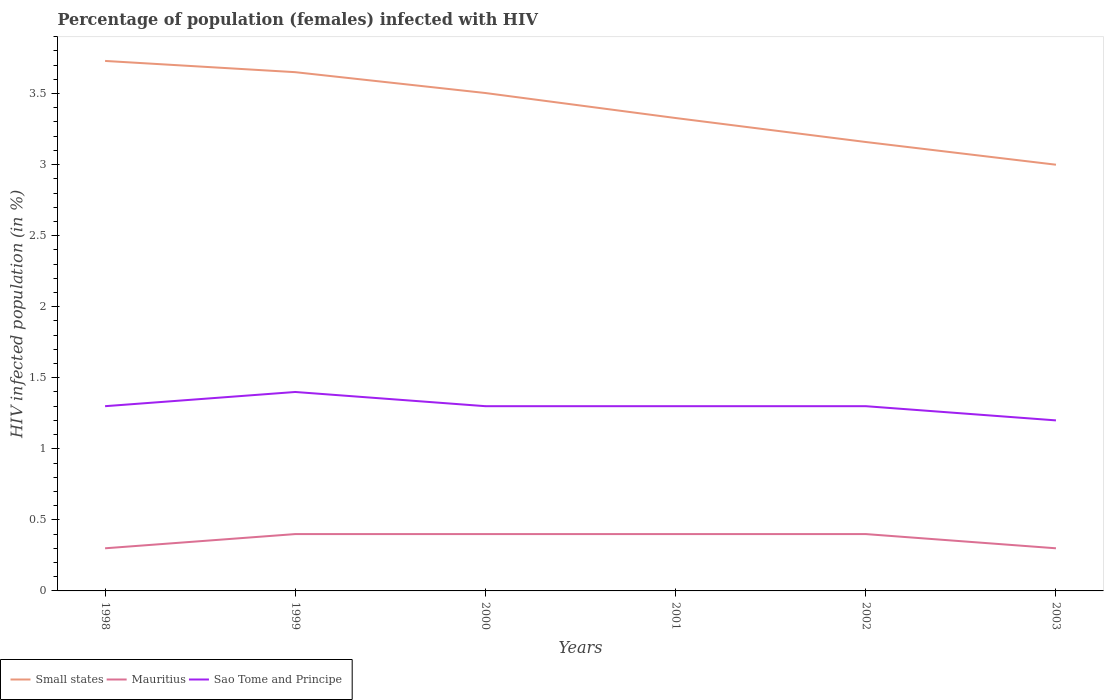How many different coloured lines are there?
Offer a terse response. 3. Does the line corresponding to Mauritius intersect with the line corresponding to Sao Tome and Principe?
Make the answer very short. No. Is the number of lines equal to the number of legend labels?
Give a very brief answer. Yes. Across all years, what is the maximum percentage of HIV infected female population in Small states?
Offer a terse response. 3. In which year was the percentage of HIV infected female population in Small states maximum?
Give a very brief answer. 2003. What is the total percentage of HIV infected female population in Mauritius in the graph?
Offer a very short reply. -0.1. What is the difference between the highest and the second highest percentage of HIV infected female population in Small states?
Provide a short and direct response. 0.73. What is the difference between the highest and the lowest percentage of HIV infected female population in Sao Tome and Principe?
Make the answer very short. 1. Is the percentage of HIV infected female population in Sao Tome and Principe strictly greater than the percentage of HIV infected female population in Mauritius over the years?
Your answer should be compact. No. How many lines are there?
Give a very brief answer. 3. How many years are there in the graph?
Ensure brevity in your answer.  6. Are the values on the major ticks of Y-axis written in scientific E-notation?
Ensure brevity in your answer.  No. Where does the legend appear in the graph?
Give a very brief answer. Bottom left. How many legend labels are there?
Ensure brevity in your answer.  3. What is the title of the graph?
Provide a succinct answer. Percentage of population (females) infected with HIV. What is the label or title of the X-axis?
Your response must be concise. Years. What is the label or title of the Y-axis?
Provide a succinct answer. HIV infected population (in %). What is the HIV infected population (in %) in Small states in 1998?
Offer a terse response. 3.73. What is the HIV infected population (in %) in Small states in 1999?
Provide a succinct answer. 3.65. What is the HIV infected population (in %) of Sao Tome and Principe in 1999?
Keep it short and to the point. 1.4. What is the HIV infected population (in %) in Small states in 2000?
Make the answer very short. 3.5. What is the HIV infected population (in %) in Mauritius in 2000?
Give a very brief answer. 0.4. What is the HIV infected population (in %) of Sao Tome and Principe in 2000?
Offer a terse response. 1.3. What is the HIV infected population (in %) of Small states in 2001?
Give a very brief answer. 3.33. What is the HIV infected population (in %) in Mauritius in 2001?
Provide a succinct answer. 0.4. What is the HIV infected population (in %) in Small states in 2002?
Your answer should be compact. 3.16. What is the HIV infected population (in %) of Mauritius in 2002?
Your answer should be very brief. 0.4. What is the HIV infected population (in %) of Small states in 2003?
Your answer should be compact. 3. Across all years, what is the maximum HIV infected population (in %) of Small states?
Give a very brief answer. 3.73. Across all years, what is the maximum HIV infected population (in %) of Mauritius?
Provide a short and direct response. 0.4. Across all years, what is the maximum HIV infected population (in %) of Sao Tome and Principe?
Your response must be concise. 1.4. Across all years, what is the minimum HIV infected population (in %) in Small states?
Your answer should be very brief. 3. Across all years, what is the minimum HIV infected population (in %) of Mauritius?
Make the answer very short. 0.3. What is the total HIV infected population (in %) of Small states in the graph?
Make the answer very short. 20.37. What is the total HIV infected population (in %) of Mauritius in the graph?
Give a very brief answer. 2.2. What is the difference between the HIV infected population (in %) of Small states in 1998 and that in 1999?
Ensure brevity in your answer.  0.08. What is the difference between the HIV infected population (in %) in Mauritius in 1998 and that in 1999?
Your response must be concise. -0.1. What is the difference between the HIV infected population (in %) of Sao Tome and Principe in 1998 and that in 1999?
Your answer should be very brief. -0.1. What is the difference between the HIV infected population (in %) in Small states in 1998 and that in 2000?
Keep it short and to the point. 0.23. What is the difference between the HIV infected population (in %) of Mauritius in 1998 and that in 2000?
Make the answer very short. -0.1. What is the difference between the HIV infected population (in %) in Sao Tome and Principe in 1998 and that in 2000?
Provide a succinct answer. 0. What is the difference between the HIV infected population (in %) of Small states in 1998 and that in 2001?
Your response must be concise. 0.4. What is the difference between the HIV infected population (in %) of Small states in 1998 and that in 2002?
Offer a very short reply. 0.57. What is the difference between the HIV infected population (in %) of Small states in 1998 and that in 2003?
Your response must be concise. 0.73. What is the difference between the HIV infected population (in %) in Mauritius in 1998 and that in 2003?
Make the answer very short. 0. What is the difference between the HIV infected population (in %) in Sao Tome and Principe in 1998 and that in 2003?
Make the answer very short. 0.1. What is the difference between the HIV infected population (in %) of Small states in 1999 and that in 2000?
Ensure brevity in your answer.  0.15. What is the difference between the HIV infected population (in %) in Sao Tome and Principe in 1999 and that in 2000?
Make the answer very short. 0.1. What is the difference between the HIV infected population (in %) of Small states in 1999 and that in 2001?
Offer a terse response. 0.32. What is the difference between the HIV infected population (in %) in Mauritius in 1999 and that in 2001?
Ensure brevity in your answer.  0. What is the difference between the HIV infected population (in %) of Sao Tome and Principe in 1999 and that in 2001?
Your answer should be very brief. 0.1. What is the difference between the HIV infected population (in %) of Small states in 1999 and that in 2002?
Offer a terse response. 0.49. What is the difference between the HIV infected population (in %) of Sao Tome and Principe in 1999 and that in 2002?
Ensure brevity in your answer.  0.1. What is the difference between the HIV infected population (in %) of Small states in 1999 and that in 2003?
Provide a succinct answer. 0.65. What is the difference between the HIV infected population (in %) of Sao Tome and Principe in 1999 and that in 2003?
Your response must be concise. 0.2. What is the difference between the HIV infected population (in %) in Small states in 2000 and that in 2001?
Keep it short and to the point. 0.18. What is the difference between the HIV infected population (in %) in Mauritius in 2000 and that in 2001?
Your response must be concise. 0. What is the difference between the HIV infected population (in %) in Small states in 2000 and that in 2002?
Offer a terse response. 0.34. What is the difference between the HIV infected population (in %) in Small states in 2000 and that in 2003?
Keep it short and to the point. 0.5. What is the difference between the HIV infected population (in %) in Small states in 2001 and that in 2002?
Your answer should be compact. 0.17. What is the difference between the HIV infected population (in %) of Mauritius in 2001 and that in 2002?
Offer a terse response. 0. What is the difference between the HIV infected population (in %) in Small states in 2001 and that in 2003?
Your answer should be compact. 0.33. What is the difference between the HIV infected population (in %) of Small states in 2002 and that in 2003?
Your answer should be very brief. 0.16. What is the difference between the HIV infected population (in %) in Sao Tome and Principe in 2002 and that in 2003?
Ensure brevity in your answer.  0.1. What is the difference between the HIV infected population (in %) in Small states in 1998 and the HIV infected population (in %) in Mauritius in 1999?
Your response must be concise. 3.33. What is the difference between the HIV infected population (in %) of Small states in 1998 and the HIV infected population (in %) of Sao Tome and Principe in 1999?
Your answer should be very brief. 2.33. What is the difference between the HIV infected population (in %) in Mauritius in 1998 and the HIV infected population (in %) in Sao Tome and Principe in 1999?
Give a very brief answer. -1.1. What is the difference between the HIV infected population (in %) in Small states in 1998 and the HIV infected population (in %) in Mauritius in 2000?
Offer a terse response. 3.33. What is the difference between the HIV infected population (in %) of Small states in 1998 and the HIV infected population (in %) of Sao Tome and Principe in 2000?
Provide a succinct answer. 2.43. What is the difference between the HIV infected population (in %) of Mauritius in 1998 and the HIV infected population (in %) of Sao Tome and Principe in 2000?
Your answer should be very brief. -1. What is the difference between the HIV infected population (in %) of Small states in 1998 and the HIV infected population (in %) of Mauritius in 2001?
Give a very brief answer. 3.33. What is the difference between the HIV infected population (in %) in Small states in 1998 and the HIV infected population (in %) in Sao Tome and Principe in 2001?
Offer a very short reply. 2.43. What is the difference between the HIV infected population (in %) of Mauritius in 1998 and the HIV infected population (in %) of Sao Tome and Principe in 2001?
Your answer should be compact. -1. What is the difference between the HIV infected population (in %) in Small states in 1998 and the HIV infected population (in %) in Mauritius in 2002?
Offer a very short reply. 3.33. What is the difference between the HIV infected population (in %) in Small states in 1998 and the HIV infected population (in %) in Sao Tome and Principe in 2002?
Offer a terse response. 2.43. What is the difference between the HIV infected population (in %) of Mauritius in 1998 and the HIV infected population (in %) of Sao Tome and Principe in 2002?
Ensure brevity in your answer.  -1. What is the difference between the HIV infected population (in %) in Small states in 1998 and the HIV infected population (in %) in Mauritius in 2003?
Provide a succinct answer. 3.43. What is the difference between the HIV infected population (in %) of Small states in 1998 and the HIV infected population (in %) of Sao Tome and Principe in 2003?
Provide a short and direct response. 2.53. What is the difference between the HIV infected population (in %) of Mauritius in 1998 and the HIV infected population (in %) of Sao Tome and Principe in 2003?
Give a very brief answer. -0.9. What is the difference between the HIV infected population (in %) in Small states in 1999 and the HIV infected population (in %) in Mauritius in 2000?
Offer a terse response. 3.25. What is the difference between the HIV infected population (in %) in Small states in 1999 and the HIV infected population (in %) in Sao Tome and Principe in 2000?
Offer a very short reply. 2.35. What is the difference between the HIV infected population (in %) in Small states in 1999 and the HIV infected population (in %) in Mauritius in 2001?
Ensure brevity in your answer.  3.25. What is the difference between the HIV infected population (in %) in Small states in 1999 and the HIV infected population (in %) in Sao Tome and Principe in 2001?
Your answer should be very brief. 2.35. What is the difference between the HIV infected population (in %) of Mauritius in 1999 and the HIV infected population (in %) of Sao Tome and Principe in 2001?
Give a very brief answer. -0.9. What is the difference between the HIV infected population (in %) of Small states in 1999 and the HIV infected population (in %) of Mauritius in 2002?
Make the answer very short. 3.25. What is the difference between the HIV infected population (in %) in Small states in 1999 and the HIV infected population (in %) in Sao Tome and Principe in 2002?
Offer a terse response. 2.35. What is the difference between the HIV infected population (in %) of Small states in 1999 and the HIV infected population (in %) of Mauritius in 2003?
Your answer should be very brief. 3.35. What is the difference between the HIV infected population (in %) of Small states in 1999 and the HIV infected population (in %) of Sao Tome and Principe in 2003?
Your answer should be very brief. 2.45. What is the difference between the HIV infected population (in %) of Mauritius in 1999 and the HIV infected population (in %) of Sao Tome and Principe in 2003?
Keep it short and to the point. -0.8. What is the difference between the HIV infected population (in %) in Small states in 2000 and the HIV infected population (in %) in Mauritius in 2001?
Your answer should be compact. 3.1. What is the difference between the HIV infected population (in %) in Small states in 2000 and the HIV infected population (in %) in Sao Tome and Principe in 2001?
Your response must be concise. 2.2. What is the difference between the HIV infected population (in %) in Mauritius in 2000 and the HIV infected population (in %) in Sao Tome and Principe in 2001?
Offer a terse response. -0.9. What is the difference between the HIV infected population (in %) in Small states in 2000 and the HIV infected population (in %) in Mauritius in 2002?
Your response must be concise. 3.1. What is the difference between the HIV infected population (in %) in Small states in 2000 and the HIV infected population (in %) in Sao Tome and Principe in 2002?
Ensure brevity in your answer.  2.2. What is the difference between the HIV infected population (in %) of Mauritius in 2000 and the HIV infected population (in %) of Sao Tome and Principe in 2002?
Your answer should be very brief. -0.9. What is the difference between the HIV infected population (in %) in Small states in 2000 and the HIV infected population (in %) in Mauritius in 2003?
Your response must be concise. 3.2. What is the difference between the HIV infected population (in %) of Small states in 2000 and the HIV infected population (in %) of Sao Tome and Principe in 2003?
Your answer should be compact. 2.3. What is the difference between the HIV infected population (in %) in Mauritius in 2000 and the HIV infected population (in %) in Sao Tome and Principe in 2003?
Offer a terse response. -0.8. What is the difference between the HIV infected population (in %) in Small states in 2001 and the HIV infected population (in %) in Mauritius in 2002?
Keep it short and to the point. 2.93. What is the difference between the HIV infected population (in %) of Small states in 2001 and the HIV infected population (in %) of Sao Tome and Principe in 2002?
Make the answer very short. 2.03. What is the difference between the HIV infected population (in %) in Small states in 2001 and the HIV infected population (in %) in Mauritius in 2003?
Your response must be concise. 3.03. What is the difference between the HIV infected population (in %) of Small states in 2001 and the HIV infected population (in %) of Sao Tome and Principe in 2003?
Offer a terse response. 2.13. What is the difference between the HIV infected population (in %) of Mauritius in 2001 and the HIV infected population (in %) of Sao Tome and Principe in 2003?
Offer a very short reply. -0.8. What is the difference between the HIV infected population (in %) of Small states in 2002 and the HIV infected population (in %) of Mauritius in 2003?
Give a very brief answer. 2.86. What is the difference between the HIV infected population (in %) in Small states in 2002 and the HIV infected population (in %) in Sao Tome and Principe in 2003?
Make the answer very short. 1.96. What is the average HIV infected population (in %) of Small states per year?
Give a very brief answer. 3.4. What is the average HIV infected population (in %) of Mauritius per year?
Your answer should be compact. 0.37. What is the average HIV infected population (in %) in Sao Tome and Principe per year?
Offer a terse response. 1.3. In the year 1998, what is the difference between the HIV infected population (in %) in Small states and HIV infected population (in %) in Mauritius?
Offer a terse response. 3.43. In the year 1998, what is the difference between the HIV infected population (in %) in Small states and HIV infected population (in %) in Sao Tome and Principe?
Offer a terse response. 2.43. In the year 1999, what is the difference between the HIV infected population (in %) in Small states and HIV infected population (in %) in Mauritius?
Provide a succinct answer. 3.25. In the year 1999, what is the difference between the HIV infected population (in %) in Small states and HIV infected population (in %) in Sao Tome and Principe?
Keep it short and to the point. 2.25. In the year 1999, what is the difference between the HIV infected population (in %) of Mauritius and HIV infected population (in %) of Sao Tome and Principe?
Make the answer very short. -1. In the year 2000, what is the difference between the HIV infected population (in %) in Small states and HIV infected population (in %) in Mauritius?
Your answer should be very brief. 3.1. In the year 2000, what is the difference between the HIV infected population (in %) of Small states and HIV infected population (in %) of Sao Tome and Principe?
Provide a succinct answer. 2.2. In the year 2000, what is the difference between the HIV infected population (in %) in Mauritius and HIV infected population (in %) in Sao Tome and Principe?
Offer a terse response. -0.9. In the year 2001, what is the difference between the HIV infected population (in %) of Small states and HIV infected population (in %) of Mauritius?
Your answer should be very brief. 2.93. In the year 2001, what is the difference between the HIV infected population (in %) in Small states and HIV infected population (in %) in Sao Tome and Principe?
Offer a very short reply. 2.03. In the year 2002, what is the difference between the HIV infected population (in %) in Small states and HIV infected population (in %) in Mauritius?
Offer a terse response. 2.76. In the year 2002, what is the difference between the HIV infected population (in %) in Small states and HIV infected population (in %) in Sao Tome and Principe?
Offer a very short reply. 1.86. In the year 2002, what is the difference between the HIV infected population (in %) of Mauritius and HIV infected population (in %) of Sao Tome and Principe?
Make the answer very short. -0.9. In the year 2003, what is the difference between the HIV infected population (in %) in Small states and HIV infected population (in %) in Mauritius?
Offer a terse response. 2.7. In the year 2003, what is the difference between the HIV infected population (in %) of Small states and HIV infected population (in %) of Sao Tome and Principe?
Offer a very short reply. 1.8. In the year 2003, what is the difference between the HIV infected population (in %) of Mauritius and HIV infected population (in %) of Sao Tome and Principe?
Ensure brevity in your answer.  -0.9. What is the ratio of the HIV infected population (in %) in Small states in 1998 to that in 1999?
Give a very brief answer. 1.02. What is the ratio of the HIV infected population (in %) of Mauritius in 1998 to that in 1999?
Provide a short and direct response. 0.75. What is the ratio of the HIV infected population (in %) in Small states in 1998 to that in 2000?
Make the answer very short. 1.06. What is the ratio of the HIV infected population (in %) in Sao Tome and Principe in 1998 to that in 2000?
Keep it short and to the point. 1. What is the ratio of the HIV infected population (in %) of Small states in 1998 to that in 2001?
Your response must be concise. 1.12. What is the ratio of the HIV infected population (in %) in Mauritius in 1998 to that in 2001?
Offer a terse response. 0.75. What is the ratio of the HIV infected population (in %) in Small states in 1998 to that in 2002?
Make the answer very short. 1.18. What is the ratio of the HIV infected population (in %) in Small states in 1998 to that in 2003?
Offer a very short reply. 1.24. What is the ratio of the HIV infected population (in %) in Sao Tome and Principe in 1998 to that in 2003?
Your answer should be very brief. 1.08. What is the ratio of the HIV infected population (in %) in Small states in 1999 to that in 2000?
Keep it short and to the point. 1.04. What is the ratio of the HIV infected population (in %) of Mauritius in 1999 to that in 2000?
Keep it short and to the point. 1. What is the ratio of the HIV infected population (in %) of Sao Tome and Principe in 1999 to that in 2000?
Provide a succinct answer. 1.08. What is the ratio of the HIV infected population (in %) in Small states in 1999 to that in 2001?
Give a very brief answer. 1.1. What is the ratio of the HIV infected population (in %) of Small states in 1999 to that in 2002?
Provide a succinct answer. 1.16. What is the ratio of the HIV infected population (in %) of Sao Tome and Principe in 1999 to that in 2002?
Your response must be concise. 1.08. What is the ratio of the HIV infected population (in %) in Small states in 1999 to that in 2003?
Ensure brevity in your answer.  1.22. What is the ratio of the HIV infected population (in %) in Sao Tome and Principe in 1999 to that in 2003?
Ensure brevity in your answer.  1.17. What is the ratio of the HIV infected population (in %) of Small states in 2000 to that in 2001?
Make the answer very short. 1.05. What is the ratio of the HIV infected population (in %) of Small states in 2000 to that in 2002?
Keep it short and to the point. 1.11. What is the ratio of the HIV infected population (in %) of Small states in 2000 to that in 2003?
Provide a succinct answer. 1.17. What is the ratio of the HIV infected population (in %) of Mauritius in 2000 to that in 2003?
Ensure brevity in your answer.  1.33. What is the ratio of the HIV infected population (in %) in Small states in 2001 to that in 2002?
Provide a succinct answer. 1.05. What is the ratio of the HIV infected population (in %) in Sao Tome and Principe in 2001 to that in 2002?
Ensure brevity in your answer.  1. What is the ratio of the HIV infected population (in %) in Small states in 2001 to that in 2003?
Provide a succinct answer. 1.11. What is the ratio of the HIV infected population (in %) of Small states in 2002 to that in 2003?
Provide a short and direct response. 1.05. What is the difference between the highest and the second highest HIV infected population (in %) of Small states?
Offer a terse response. 0.08. What is the difference between the highest and the second highest HIV infected population (in %) of Sao Tome and Principe?
Give a very brief answer. 0.1. What is the difference between the highest and the lowest HIV infected population (in %) of Small states?
Offer a terse response. 0.73. What is the difference between the highest and the lowest HIV infected population (in %) in Sao Tome and Principe?
Provide a short and direct response. 0.2. 